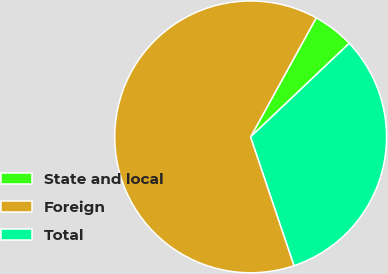Convert chart. <chart><loc_0><loc_0><loc_500><loc_500><pie_chart><fcel>State and local<fcel>Foreign<fcel>Total<nl><fcel>4.91%<fcel>63.19%<fcel>31.9%<nl></chart> 